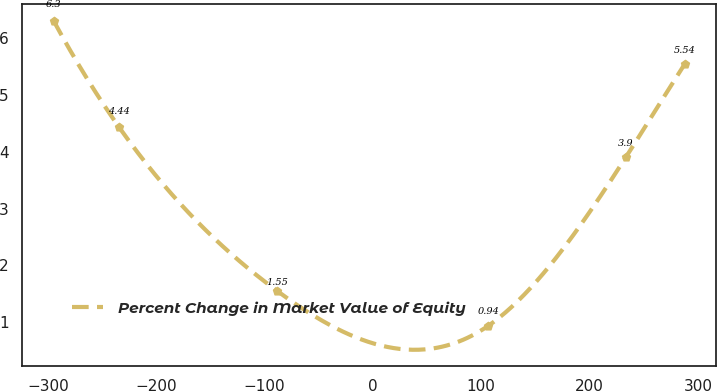<chart> <loc_0><loc_0><loc_500><loc_500><line_chart><ecel><fcel>Percent Change in Market Value of Equity<nl><fcel>-294.7<fcel>6.3<nl><fcel>-234.63<fcel>4.44<nl><fcel>-88.13<fcel>1.55<nl><fcel>106.47<fcel>0.94<nl><fcel>233.46<fcel>3.9<nl><fcel>287.88<fcel>5.54<nl></chart> 